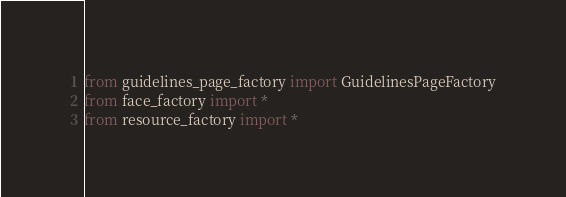Convert code to text. <code><loc_0><loc_0><loc_500><loc_500><_Python_>from guidelines_page_factory import GuidelinesPageFactory
from face_factory import *
from resource_factory import *</code> 